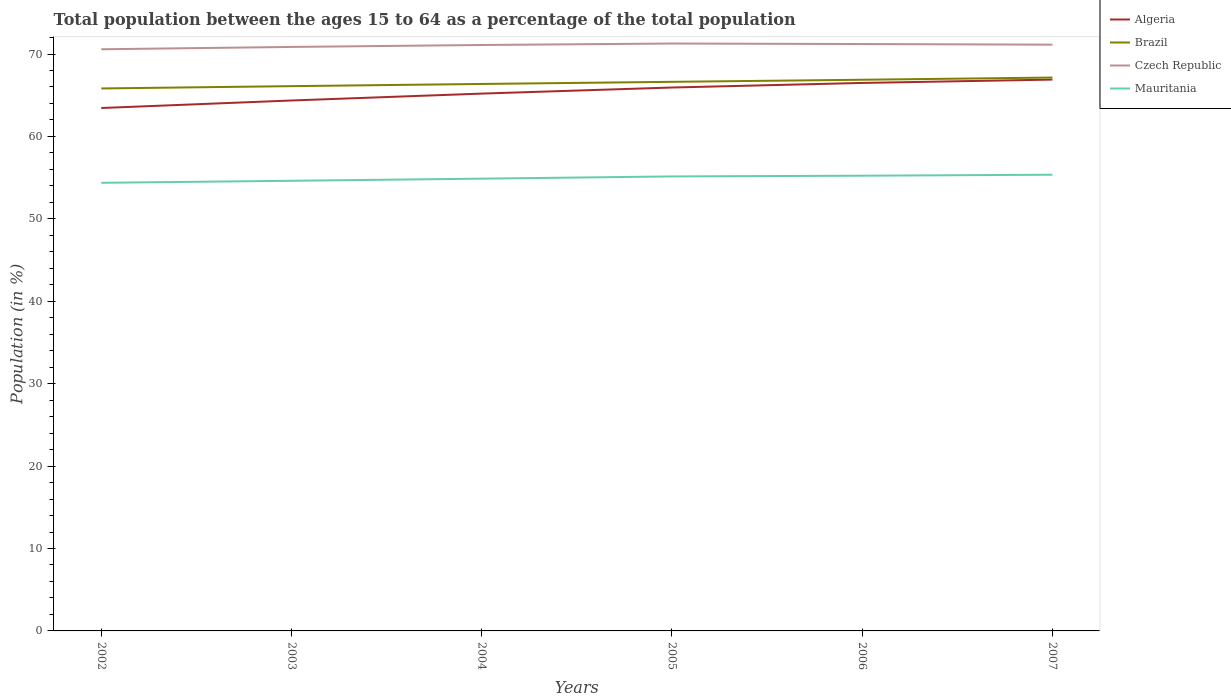How many different coloured lines are there?
Give a very brief answer. 4. Across all years, what is the maximum percentage of the population ages 15 to 64 in Algeria?
Provide a succinct answer. 63.45. What is the total percentage of the population ages 15 to 64 in Brazil in the graph?
Keep it short and to the point. -0.27. What is the difference between the highest and the second highest percentage of the population ages 15 to 64 in Algeria?
Give a very brief answer. 3.45. Is the percentage of the population ages 15 to 64 in Mauritania strictly greater than the percentage of the population ages 15 to 64 in Czech Republic over the years?
Your answer should be compact. Yes. How many lines are there?
Your answer should be very brief. 4. How many years are there in the graph?
Provide a short and direct response. 6. What is the difference between two consecutive major ticks on the Y-axis?
Your answer should be very brief. 10. Are the values on the major ticks of Y-axis written in scientific E-notation?
Provide a succinct answer. No. Does the graph contain any zero values?
Provide a short and direct response. No. Where does the legend appear in the graph?
Provide a succinct answer. Top right. How many legend labels are there?
Make the answer very short. 4. What is the title of the graph?
Keep it short and to the point. Total population between the ages 15 to 64 as a percentage of the total population. What is the label or title of the Y-axis?
Give a very brief answer. Population (in %). What is the Population (in %) of Algeria in 2002?
Your answer should be compact. 63.45. What is the Population (in %) of Brazil in 2002?
Make the answer very short. 65.82. What is the Population (in %) in Czech Republic in 2002?
Your answer should be very brief. 70.57. What is the Population (in %) in Mauritania in 2002?
Keep it short and to the point. 54.37. What is the Population (in %) of Algeria in 2003?
Your answer should be very brief. 64.36. What is the Population (in %) in Brazil in 2003?
Your answer should be compact. 66.1. What is the Population (in %) of Czech Republic in 2003?
Provide a short and direct response. 70.86. What is the Population (in %) of Mauritania in 2003?
Offer a very short reply. 54.62. What is the Population (in %) of Algeria in 2004?
Give a very brief answer. 65.2. What is the Population (in %) of Brazil in 2004?
Your response must be concise. 66.37. What is the Population (in %) in Czech Republic in 2004?
Make the answer very short. 71.09. What is the Population (in %) of Mauritania in 2004?
Keep it short and to the point. 54.88. What is the Population (in %) in Algeria in 2005?
Your response must be concise. 65.93. What is the Population (in %) in Brazil in 2005?
Your response must be concise. 66.62. What is the Population (in %) in Czech Republic in 2005?
Ensure brevity in your answer.  71.27. What is the Population (in %) in Mauritania in 2005?
Keep it short and to the point. 55.15. What is the Population (in %) of Algeria in 2006?
Give a very brief answer. 66.49. What is the Population (in %) in Brazil in 2006?
Your answer should be compact. 66.88. What is the Population (in %) of Czech Republic in 2006?
Your response must be concise. 71.21. What is the Population (in %) of Mauritania in 2006?
Ensure brevity in your answer.  55.23. What is the Population (in %) in Algeria in 2007?
Offer a very short reply. 66.9. What is the Population (in %) in Brazil in 2007?
Your answer should be very brief. 67.14. What is the Population (in %) in Czech Republic in 2007?
Offer a very short reply. 71.13. What is the Population (in %) in Mauritania in 2007?
Your answer should be very brief. 55.35. Across all years, what is the maximum Population (in %) in Algeria?
Offer a terse response. 66.9. Across all years, what is the maximum Population (in %) of Brazil?
Make the answer very short. 67.14. Across all years, what is the maximum Population (in %) in Czech Republic?
Offer a very short reply. 71.27. Across all years, what is the maximum Population (in %) in Mauritania?
Make the answer very short. 55.35. Across all years, what is the minimum Population (in %) in Algeria?
Make the answer very short. 63.45. Across all years, what is the minimum Population (in %) of Brazil?
Give a very brief answer. 65.82. Across all years, what is the minimum Population (in %) of Czech Republic?
Your answer should be compact. 70.57. Across all years, what is the minimum Population (in %) of Mauritania?
Ensure brevity in your answer.  54.37. What is the total Population (in %) of Algeria in the graph?
Provide a short and direct response. 392.32. What is the total Population (in %) of Brazil in the graph?
Your answer should be very brief. 398.93. What is the total Population (in %) in Czech Republic in the graph?
Ensure brevity in your answer.  426.14. What is the total Population (in %) in Mauritania in the graph?
Provide a succinct answer. 329.6. What is the difference between the Population (in %) of Algeria in 2002 and that in 2003?
Your answer should be very brief. -0.91. What is the difference between the Population (in %) in Brazil in 2002 and that in 2003?
Offer a terse response. -0.28. What is the difference between the Population (in %) in Czech Republic in 2002 and that in 2003?
Ensure brevity in your answer.  -0.28. What is the difference between the Population (in %) of Mauritania in 2002 and that in 2003?
Give a very brief answer. -0.24. What is the difference between the Population (in %) of Algeria in 2002 and that in 2004?
Your answer should be compact. -1.75. What is the difference between the Population (in %) of Brazil in 2002 and that in 2004?
Give a very brief answer. -0.55. What is the difference between the Population (in %) in Czech Republic in 2002 and that in 2004?
Offer a terse response. -0.52. What is the difference between the Population (in %) of Mauritania in 2002 and that in 2004?
Keep it short and to the point. -0.5. What is the difference between the Population (in %) of Algeria in 2002 and that in 2005?
Your answer should be compact. -2.49. What is the difference between the Population (in %) in Brazil in 2002 and that in 2005?
Give a very brief answer. -0.8. What is the difference between the Population (in %) in Czech Republic in 2002 and that in 2005?
Ensure brevity in your answer.  -0.7. What is the difference between the Population (in %) in Mauritania in 2002 and that in 2005?
Your response must be concise. -0.77. What is the difference between the Population (in %) of Algeria in 2002 and that in 2006?
Keep it short and to the point. -3.04. What is the difference between the Population (in %) in Brazil in 2002 and that in 2006?
Your response must be concise. -1.05. What is the difference between the Population (in %) of Czech Republic in 2002 and that in 2006?
Offer a terse response. -0.64. What is the difference between the Population (in %) of Mauritania in 2002 and that in 2006?
Your response must be concise. -0.86. What is the difference between the Population (in %) of Algeria in 2002 and that in 2007?
Offer a very short reply. -3.45. What is the difference between the Population (in %) of Brazil in 2002 and that in 2007?
Offer a terse response. -1.32. What is the difference between the Population (in %) in Czech Republic in 2002 and that in 2007?
Your answer should be compact. -0.56. What is the difference between the Population (in %) of Mauritania in 2002 and that in 2007?
Provide a short and direct response. -0.98. What is the difference between the Population (in %) of Algeria in 2003 and that in 2004?
Keep it short and to the point. -0.84. What is the difference between the Population (in %) of Brazil in 2003 and that in 2004?
Provide a succinct answer. -0.27. What is the difference between the Population (in %) in Czech Republic in 2003 and that in 2004?
Provide a short and direct response. -0.24. What is the difference between the Population (in %) in Mauritania in 2003 and that in 2004?
Your answer should be compact. -0.26. What is the difference between the Population (in %) of Algeria in 2003 and that in 2005?
Make the answer very short. -1.57. What is the difference between the Population (in %) of Brazil in 2003 and that in 2005?
Your answer should be very brief. -0.52. What is the difference between the Population (in %) of Czech Republic in 2003 and that in 2005?
Ensure brevity in your answer.  -0.41. What is the difference between the Population (in %) in Mauritania in 2003 and that in 2005?
Give a very brief answer. -0.53. What is the difference between the Population (in %) of Algeria in 2003 and that in 2006?
Ensure brevity in your answer.  -2.13. What is the difference between the Population (in %) in Brazil in 2003 and that in 2006?
Your response must be concise. -0.78. What is the difference between the Population (in %) in Czech Republic in 2003 and that in 2006?
Offer a terse response. -0.35. What is the difference between the Population (in %) of Mauritania in 2003 and that in 2006?
Offer a terse response. -0.62. What is the difference between the Population (in %) of Algeria in 2003 and that in 2007?
Ensure brevity in your answer.  -2.54. What is the difference between the Population (in %) in Brazil in 2003 and that in 2007?
Offer a very short reply. -1.04. What is the difference between the Population (in %) in Czech Republic in 2003 and that in 2007?
Offer a very short reply. -0.28. What is the difference between the Population (in %) in Mauritania in 2003 and that in 2007?
Your answer should be very brief. -0.74. What is the difference between the Population (in %) in Algeria in 2004 and that in 2005?
Your response must be concise. -0.74. What is the difference between the Population (in %) in Brazil in 2004 and that in 2005?
Make the answer very short. -0.26. What is the difference between the Population (in %) in Czech Republic in 2004 and that in 2005?
Make the answer very short. -0.18. What is the difference between the Population (in %) in Mauritania in 2004 and that in 2005?
Offer a very short reply. -0.27. What is the difference between the Population (in %) in Algeria in 2004 and that in 2006?
Your answer should be compact. -1.29. What is the difference between the Population (in %) in Brazil in 2004 and that in 2006?
Provide a short and direct response. -0.51. What is the difference between the Population (in %) in Czech Republic in 2004 and that in 2006?
Ensure brevity in your answer.  -0.12. What is the difference between the Population (in %) of Mauritania in 2004 and that in 2006?
Keep it short and to the point. -0.36. What is the difference between the Population (in %) in Algeria in 2004 and that in 2007?
Your answer should be compact. -1.7. What is the difference between the Population (in %) in Brazil in 2004 and that in 2007?
Offer a terse response. -0.78. What is the difference between the Population (in %) of Czech Republic in 2004 and that in 2007?
Offer a very short reply. -0.04. What is the difference between the Population (in %) of Mauritania in 2004 and that in 2007?
Your answer should be very brief. -0.48. What is the difference between the Population (in %) of Algeria in 2005 and that in 2006?
Your answer should be very brief. -0.55. What is the difference between the Population (in %) of Brazil in 2005 and that in 2006?
Make the answer very short. -0.25. What is the difference between the Population (in %) of Czech Republic in 2005 and that in 2006?
Give a very brief answer. 0.06. What is the difference between the Population (in %) of Mauritania in 2005 and that in 2006?
Provide a short and direct response. -0.09. What is the difference between the Population (in %) of Algeria in 2005 and that in 2007?
Provide a succinct answer. -0.96. What is the difference between the Population (in %) in Brazil in 2005 and that in 2007?
Keep it short and to the point. -0.52. What is the difference between the Population (in %) in Czech Republic in 2005 and that in 2007?
Make the answer very short. 0.14. What is the difference between the Population (in %) of Mauritania in 2005 and that in 2007?
Keep it short and to the point. -0.21. What is the difference between the Population (in %) in Algeria in 2006 and that in 2007?
Your response must be concise. -0.41. What is the difference between the Population (in %) of Brazil in 2006 and that in 2007?
Your answer should be very brief. -0.27. What is the difference between the Population (in %) in Czech Republic in 2006 and that in 2007?
Give a very brief answer. 0.08. What is the difference between the Population (in %) of Mauritania in 2006 and that in 2007?
Give a very brief answer. -0.12. What is the difference between the Population (in %) in Algeria in 2002 and the Population (in %) in Brazil in 2003?
Offer a terse response. -2.65. What is the difference between the Population (in %) of Algeria in 2002 and the Population (in %) of Czech Republic in 2003?
Provide a succinct answer. -7.41. What is the difference between the Population (in %) in Algeria in 2002 and the Population (in %) in Mauritania in 2003?
Offer a terse response. 8.83. What is the difference between the Population (in %) of Brazil in 2002 and the Population (in %) of Czech Republic in 2003?
Make the answer very short. -5.04. What is the difference between the Population (in %) of Brazil in 2002 and the Population (in %) of Mauritania in 2003?
Make the answer very short. 11.2. What is the difference between the Population (in %) in Czech Republic in 2002 and the Population (in %) in Mauritania in 2003?
Your response must be concise. 15.96. What is the difference between the Population (in %) of Algeria in 2002 and the Population (in %) of Brazil in 2004?
Ensure brevity in your answer.  -2.92. What is the difference between the Population (in %) of Algeria in 2002 and the Population (in %) of Czech Republic in 2004?
Offer a very short reply. -7.65. What is the difference between the Population (in %) of Algeria in 2002 and the Population (in %) of Mauritania in 2004?
Ensure brevity in your answer.  8.57. What is the difference between the Population (in %) of Brazil in 2002 and the Population (in %) of Czech Republic in 2004?
Make the answer very short. -5.27. What is the difference between the Population (in %) of Brazil in 2002 and the Population (in %) of Mauritania in 2004?
Offer a terse response. 10.95. What is the difference between the Population (in %) in Czech Republic in 2002 and the Population (in %) in Mauritania in 2004?
Your response must be concise. 15.7. What is the difference between the Population (in %) in Algeria in 2002 and the Population (in %) in Brazil in 2005?
Offer a very short reply. -3.18. What is the difference between the Population (in %) of Algeria in 2002 and the Population (in %) of Czech Republic in 2005?
Provide a short and direct response. -7.82. What is the difference between the Population (in %) of Algeria in 2002 and the Population (in %) of Mauritania in 2005?
Your answer should be compact. 8.3. What is the difference between the Population (in %) of Brazil in 2002 and the Population (in %) of Czech Republic in 2005?
Provide a short and direct response. -5.45. What is the difference between the Population (in %) in Brazil in 2002 and the Population (in %) in Mauritania in 2005?
Provide a short and direct response. 10.67. What is the difference between the Population (in %) of Czech Republic in 2002 and the Population (in %) of Mauritania in 2005?
Your answer should be very brief. 15.43. What is the difference between the Population (in %) of Algeria in 2002 and the Population (in %) of Brazil in 2006?
Ensure brevity in your answer.  -3.43. What is the difference between the Population (in %) in Algeria in 2002 and the Population (in %) in Czech Republic in 2006?
Provide a short and direct response. -7.76. What is the difference between the Population (in %) of Algeria in 2002 and the Population (in %) of Mauritania in 2006?
Ensure brevity in your answer.  8.21. What is the difference between the Population (in %) in Brazil in 2002 and the Population (in %) in Czech Republic in 2006?
Give a very brief answer. -5.39. What is the difference between the Population (in %) in Brazil in 2002 and the Population (in %) in Mauritania in 2006?
Your response must be concise. 10.59. What is the difference between the Population (in %) of Czech Republic in 2002 and the Population (in %) of Mauritania in 2006?
Give a very brief answer. 15.34. What is the difference between the Population (in %) in Algeria in 2002 and the Population (in %) in Brazil in 2007?
Ensure brevity in your answer.  -3.7. What is the difference between the Population (in %) of Algeria in 2002 and the Population (in %) of Czech Republic in 2007?
Provide a succinct answer. -7.69. What is the difference between the Population (in %) of Algeria in 2002 and the Population (in %) of Mauritania in 2007?
Offer a very short reply. 8.09. What is the difference between the Population (in %) of Brazil in 2002 and the Population (in %) of Czech Republic in 2007?
Your answer should be compact. -5.31. What is the difference between the Population (in %) in Brazil in 2002 and the Population (in %) in Mauritania in 2007?
Keep it short and to the point. 10.47. What is the difference between the Population (in %) in Czech Republic in 2002 and the Population (in %) in Mauritania in 2007?
Give a very brief answer. 15.22. What is the difference between the Population (in %) of Algeria in 2003 and the Population (in %) of Brazil in 2004?
Keep it short and to the point. -2.01. What is the difference between the Population (in %) in Algeria in 2003 and the Population (in %) in Czech Republic in 2004?
Offer a very short reply. -6.73. What is the difference between the Population (in %) of Algeria in 2003 and the Population (in %) of Mauritania in 2004?
Give a very brief answer. 9.48. What is the difference between the Population (in %) of Brazil in 2003 and the Population (in %) of Czech Republic in 2004?
Offer a very short reply. -4.99. What is the difference between the Population (in %) of Brazil in 2003 and the Population (in %) of Mauritania in 2004?
Make the answer very short. 11.23. What is the difference between the Population (in %) in Czech Republic in 2003 and the Population (in %) in Mauritania in 2004?
Offer a very short reply. 15.98. What is the difference between the Population (in %) in Algeria in 2003 and the Population (in %) in Brazil in 2005?
Provide a succinct answer. -2.26. What is the difference between the Population (in %) of Algeria in 2003 and the Population (in %) of Czech Republic in 2005?
Your response must be concise. -6.91. What is the difference between the Population (in %) of Algeria in 2003 and the Population (in %) of Mauritania in 2005?
Provide a succinct answer. 9.21. What is the difference between the Population (in %) of Brazil in 2003 and the Population (in %) of Czech Republic in 2005?
Keep it short and to the point. -5.17. What is the difference between the Population (in %) in Brazil in 2003 and the Population (in %) in Mauritania in 2005?
Your answer should be very brief. 10.95. What is the difference between the Population (in %) of Czech Republic in 2003 and the Population (in %) of Mauritania in 2005?
Your answer should be compact. 15.71. What is the difference between the Population (in %) in Algeria in 2003 and the Population (in %) in Brazil in 2006?
Ensure brevity in your answer.  -2.52. What is the difference between the Population (in %) in Algeria in 2003 and the Population (in %) in Czech Republic in 2006?
Keep it short and to the point. -6.85. What is the difference between the Population (in %) in Algeria in 2003 and the Population (in %) in Mauritania in 2006?
Provide a short and direct response. 9.13. What is the difference between the Population (in %) of Brazil in 2003 and the Population (in %) of Czech Republic in 2006?
Offer a terse response. -5.11. What is the difference between the Population (in %) of Brazil in 2003 and the Population (in %) of Mauritania in 2006?
Offer a terse response. 10.87. What is the difference between the Population (in %) in Czech Republic in 2003 and the Population (in %) in Mauritania in 2006?
Give a very brief answer. 15.62. What is the difference between the Population (in %) of Algeria in 2003 and the Population (in %) of Brazil in 2007?
Provide a succinct answer. -2.78. What is the difference between the Population (in %) in Algeria in 2003 and the Population (in %) in Czech Republic in 2007?
Give a very brief answer. -6.77. What is the difference between the Population (in %) in Algeria in 2003 and the Population (in %) in Mauritania in 2007?
Provide a short and direct response. 9.01. What is the difference between the Population (in %) of Brazil in 2003 and the Population (in %) of Czech Republic in 2007?
Give a very brief answer. -5.03. What is the difference between the Population (in %) in Brazil in 2003 and the Population (in %) in Mauritania in 2007?
Ensure brevity in your answer.  10.75. What is the difference between the Population (in %) of Czech Republic in 2003 and the Population (in %) of Mauritania in 2007?
Provide a succinct answer. 15.5. What is the difference between the Population (in %) in Algeria in 2004 and the Population (in %) in Brazil in 2005?
Give a very brief answer. -1.43. What is the difference between the Population (in %) in Algeria in 2004 and the Population (in %) in Czech Republic in 2005?
Offer a very short reply. -6.07. What is the difference between the Population (in %) in Algeria in 2004 and the Population (in %) in Mauritania in 2005?
Give a very brief answer. 10.05. What is the difference between the Population (in %) of Brazil in 2004 and the Population (in %) of Czech Republic in 2005?
Provide a short and direct response. -4.9. What is the difference between the Population (in %) in Brazil in 2004 and the Population (in %) in Mauritania in 2005?
Offer a terse response. 11.22. What is the difference between the Population (in %) of Czech Republic in 2004 and the Population (in %) of Mauritania in 2005?
Give a very brief answer. 15.95. What is the difference between the Population (in %) in Algeria in 2004 and the Population (in %) in Brazil in 2006?
Keep it short and to the point. -1.68. What is the difference between the Population (in %) of Algeria in 2004 and the Population (in %) of Czech Republic in 2006?
Give a very brief answer. -6.01. What is the difference between the Population (in %) of Algeria in 2004 and the Population (in %) of Mauritania in 2006?
Give a very brief answer. 9.96. What is the difference between the Population (in %) in Brazil in 2004 and the Population (in %) in Czech Republic in 2006?
Your answer should be compact. -4.84. What is the difference between the Population (in %) in Brazil in 2004 and the Population (in %) in Mauritania in 2006?
Keep it short and to the point. 11.13. What is the difference between the Population (in %) in Czech Republic in 2004 and the Population (in %) in Mauritania in 2006?
Your answer should be very brief. 15.86. What is the difference between the Population (in %) in Algeria in 2004 and the Population (in %) in Brazil in 2007?
Make the answer very short. -1.95. What is the difference between the Population (in %) in Algeria in 2004 and the Population (in %) in Czech Republic in 2007?
Your answer should be very brief. -5.94. What is the difference between the Population (in %) in Algeria in 2004 and the Population (in %) in Mauritania in 2007?
Offer a terse response. 9.84. What is the difference between the Population (in %) of Brazil in 2004 and the Population (in %) of Czech Republic in 2007?
Make the answer very short. -4.77. What is the difference between the Population (in %) in Brazil in 2004 and the Population (in %) in Mauritania in 2007?
Offer a terse response. 11.01. What is the difference between the Population (in %) in Czech Republic in 2004 and the Population (in %) in Mauritania in 2007?
Offer a terse response. 15.74. What is the difference between the Population (in %) in Algeria in 2005 and the Population (in %) in Brazil in 2006?
Ensure brevity in your answer.  -0.94. What is the difference between the Population (in %) in Algeria in 2005 and the Population (in %) in Czech Republic in 2006?
Keep it short and to the point. -5.28. What is the difference between the Population (in %) of Algeria in 2005 and the Population (in %) of Mauritania in 2006?
Provide a short and direct response. 10.7. What is the difference between the Population (in %) in Brazil in 2005 and the Population (in %) in Czech Republic in 2006?
Ensure brevity in your answer.  -4.59. What is the difference between the Population (in %) of Brazil in 2005 and the Population (in %) of Mauritania in 2006?
Provide a succinct answer. 11.39. What is the difference between the Population (in %) in Czech Republic in 2005 and the Population (in %) in Mauritania in 2006?
Provide a succinct answer. 16.04. What is the difference between the Population (in %) of Algeria in 2005 and the Population (in %) of Brazil in 2007?
Ensure brevity in your answer.  -1.21. What is the difference between the Population (in %) of Algeria in 2005 and the Population (in %) of Czech Republic in 2007?
Your response must be concise. -5.2. What is the difference between the Population (in %) in Algeria in 2005 and the Population (in %) in Mauritania in 2007?
Offer a terse response. 10.58. What is the difference between the Population (in %) of Brazil in 2005 and the Population (in %) of Czech Republic in 2007?
Provide a succinct answer. -4.51. What is the difference between the Population (in %) in Brazil in 2005 and the Population (in %) in Mauritania in 2007?
Provide a succinct answer. 11.27. What is the difference between the Population (in %) of Czech Republic in 2005 and the Population (in %) of Mauritania in 2007?
Your answer should be compact. 15.92. What is the difference between the Population (in %) of Algeria in 2006 and the Population (in %) of Brazil in 2007?
Offer a very short reply. -0.66. What is the difference between the Population (in %) of Algeria in 2006 and the Population (in %) of Czech Republic in 2007?
Your response must be concise. -4.64. What is the difference between the Population (in %) in Algeria in 2006 and the Population (in %) in Mauritania in 2007?
Make the answer very short. 11.14. What is the difference between the Population (in %) of Brazil in 2006 and the Population (in %) of Czech Republic in 2007?
Make the answer very short. -4.26. What is the difference between the Population (in %) in Brazil in 2006 and the Population (in %) in Mauritania in 2007?
Your response must be concise. 11.52. What is the difference between the Population (in %) of Czech Republic in 2006 and the Population (in %) of Mauritania in 2007?
Your answer should be very brief. 15.86. What is the average Population (in %) of Algeria per year?
Make the answer very short. 65.39. What is the average Population (in %) of Brazil per year?
Provide a short and direct response. 66.49. What is the average Population (in %) of Czech Republic per year?
Keep it short and to the point. 71.02. What is the average Population (in %) of Mauritania per year?
Keep it short and to the point. 54.93. In the year 2002, what is the difference between the Population (in %) of Algeria and Population (in %) of Brazil?
Ensure brevity in your answer.  -2.37. In the year 2002, what is the difference between the Population (in %) in Algeria and Population (in %) in Czech Republic?
Offer a terse response. -7.13. In the year 2002, what is the difference between the Population (in %) of Algeria and Population (in %) of Mauritania?
Your response must be concise. 9.07. In the year 2002, what is the difference between the Population (in %) in Brazil and Population (in %) in Czech Republic?
Provide a succinct answer. -4.75. In the year 2002, what is the difference between the Population (in %) of Brazil and Population (in %) of Mauritania?
Keep it short and to the point. 11.45. In the year 2002, what is the difference between the Population (in %) of Czech Republic and Population (in %) of Mauritania?
Ensure brevity in your answer.  16.2. In the year 2003, what is the difference between the Population (in %) of Algeria and Population (in %) of Brazil?
Offer a terse response. -1.74. In the year 2003, what is the difference between the Population (in %) in Algeria and Population (in %) in Czech Republic?
Your answer should be compact. -6.5. In the year 2003, what is the difference between the Population (in %) in Algeria and Population (in %) in Mauritania?
Your response must be concise. 9.74. In the year 2003, what is the difference between the Population (in %) in Brazil and Population (in %) in Czech Republic?
Your answer should be compact. -4.76. In the year 2003, what is the difference between the Population (in %) of Brazil and Population (in %) of Mauritania?
Ensure brevity in your answer.  11.48. In the year 2003, what is the difference between the Population (in %) in Czech Republic and Population (in %) in Mauritania?
Provide a succinct answer. 16.24. In the year 2004, what is the difference between the Population (in %) in Algeria and Population (in %) in Brazil?
Your response must be concise. -1.17. In the year 2004, what is the difference between the Population (in %) in Algeria and Population (in %) in Czech Republic?
Offer a terse response. -5.9. In the year 2004, what is the difference between the Population (in %) of Algeria and Population (in %) of Mauritania?
Offer a terse response. 10.32. In the year 2004, what is the difference between the Population (in %) of Brazil and Population (in %) of Czech Republic?
Give a very brief answer. -4.73. In the year 2004, what is the difference between the Population (in %) in Brazil and Population (in %) in Mauritania?
Offer a terse response. 11.49. In the year 2004, what is the difference between the Population (in %) of Czech Republic and Population (in %) of Mauritania?
Offer a very short reply. 16.22. In the year 2005, what is the difference between the Population (in %) in Algeria and Population (in %) in Brazil?
Ensure brevity in your answer.  -0.69. In the year 2005, what is the difference between the Population (in %) in Algeria and Population (in %) in Czech Republic?
Offer a very short reply. -5.34. In the year 2005, what is the difference between the Population (in %) of Algeria and Population (in %) of Mauritania?
Your response must be concise. 10.79. In the year 2005, what is the difference between the Population (in %) of Brazil and Population (in %) of Czech Republic?
Keep it short and to the point. -4.65. In the year 2005, what is the difference between the Population (in %) of Brazil and Population (in %) of Mauritania?
Give a very brief answer. 11.48. In the year 2005, what is the difference between the Population (in %) of Czech Republic and Population (in %) of Mauritania?
Your response must be concise. 16.12. In the year 2006, what is the difference between the Population (in %) of Algeria and Population (in %) of Brazil?
Your answer should be very brief. -0.39. In the year 2006, what is the difference between the Population (in %) of Algeria and Population (in %) of Czech Republic?
Offer a terse response. -4.72. In the year 2006, what is the difference between the Population (in %) of Algeria and Population (in %) of Mauritania?
Make the answer very short. 11.25. In the year 2006, what is the difference between the Population (in %) in Brazil and Population (in %) in Czech Republic?
Offer a terse response. -4.34. In the year 2006, what is the difference between the Population (in %) in Brazil and Population (in %) in Mauritania?
Ensure brevity in your answer.  11.64. In the year 2006, what is the difference between the Population (in %) in Czech Republic and Population (in %) in Mauritania?
Keep it short and to the point. 15.98. In the year 2007, what is the difference between the Population (in %) of Algeria and Population (in %) of Brazil?
Offer a terse response. -0.25. In the year 2007, what is the difference between the Population (in %) of Algeria and Population (in %) of Czech Republic?
Keep it short and to the point. -4.24. In the year 2007, what is the difference between the Population (in %) in Algeria and Population (in %) in Mauritania?
Your answer should be compact. 11.54. In the year 2007, what is the difference between the Population (in %) in Brazil and Population (in %) in Czech Republic?
Offer a very short reply. -3.99. In the year 2007, what is the difference between the Population (in %) in Brazil and Population (in %) in Mauritania?
Your answer should be very brief. 11.79. In the year 2007, what is the difference between the Population (in %) of Czech Republic and Population (in %) of Mauritania?
Ensure brevity in your answer.  15.78. What is the ratio of the Population (in %) of Algeria in 2002 to that in 2003?
Your answer should be compact. 0.99. What is the ratio of the Population (in %) in Brazil in 2002 to that in 2003?
Offer a very short reply. 1. What is the ratio of the Population (in %) in Algeria in 2002 to that in 2004?
Your answer should be compact. 0.97. What is the ratio of the Population (in %) of Czech Republic in 2002 to that in 2004?
Provide a succinct answer. 0.99. What is the ratio of the Population (in %) in Mauritania in 2002 to that in 2004?
Your answer should be compact. 0.99. What is the ratio of the Population (in %) of Algeria in 2002 to that in 2005?
Ensure brevity in your answer.  0.96. What is the ratio of the Population (in %) in Brazil in 2002 to that in 2005?
Make the answer very short. 0.99. What is the ratio of the Population (in %) of Czech Republic in 2002 to that in 2005?
Provide a succinct answer. 0.99. What is the ratio of the Population (in %) in Algeria in 2002 to that in 2006?
Provide a short and direct response. 0.95. What is the ratio of the Population (in %) in Brazil in 2002 to that in 2006?
Provide a short and direct response. 0.98. What is the ratio of the Population (in %) of Czech Republic in 2002 to that in 2006?
Offer a very short reply. 0.99. What is the ratio of the Population (in %) of Mauritania in 2002 to that in 2006?
Offer a terse response. 0.98. What is the ratio of the Population (in %) in Algeria in 2002 to that in 2007?
Your answer should be very brief. 0.95. What is the ratio of the Population (in %) in Brazil in 2002 to that in 2007?
Give a very brief answer. 0.98. What is the ratio of the Population (in %) of Czech Republic in 2002 to that in 2007?
Your answer should be compact. 0.99. What is the ratio of the Population (in %) of Mauritania in 2002 to that in 2007?
Keep it short and to the point. 0.98. What is the ratio of the Population (in %) of Algeria in 2003 to that in 2004?
Ensure brevity in your answer.  0.99. What is the ratio of the Population (in %) in Czech Republic in 2003 to that in 2004?
Give a very brief answer. 1. What is the ratio of the Population (in %) of Mauritania in 2003 to that in 2004?
Offer a terse response. 1. What is the ratio of the Population (in %) in Algeria in 2003 to that in 2005?
Offer a terse response. 0.98. What is the ratio of the Population (in %) in Brazil in 2003 to that in 2005?
Provide a succinct answer. 0.99. What is the ratio of the Population (in %) of Czech Republic in 2003 to that in 2005?
Your answer should be compact. 0.99. What is the ratio of the Population (in %) of Brazil in 2003 to that in 2006?
Your answer should be very brief. 0.99. What is the ratio of the Population (in %) in Algeria in 2003 to that in 2007?
Offer a terse response. 0.96. What is the ratio of the Population (in %) of Brazil in 2003 to that in 2007?
Give a very brief answer. 0.98. What is the ratio of the Population (in %) of Mauritania in 2003 to that in 2007?
Your response must be concise. 0.99. What is the ratio of the Population (in %) in Czech Republic in 2004 to that in 2005?
Offer a terse response. 1. What is the ratio of the Population (in %) of Mauritania in 2004 to that in 2005?
Give a very brief answer. 1. What is the ratio of the Population (in %) in Algeria in 2004 to that in 2006?
Make the answer very short. 0.98. What is the ratio of the Population (in %) in Brazil in 2004 to that in 2006?
Offer a very short reply. 0.99. What is the ratio of the Population (in %) of Czech Republic in 2004 to that in 2006?
Your answer should be compact. 1. What is the ratio of the Population (in %) in Algeria in 2004 to that in 2007?
Ensure brevity in your answer.  0.97. What is the ratio of the Population (in %) of Brazil in 2004 to that in 2007?
Provide a short and direct response. 0.99. What is the ratio of the Population (in %) in Czech Republic in 2004 to that in 2007?
Keep it short and to the point. 1. What is the ratio of the Population (in %) in Algeria in 2005 to that in 2006?
Offer a very short reply. 0.99. What is the ratio of the Population (in %) in Mauritania in 2005 to that in 2006?
Offer a very short reply. 1. What is the ratio of the Population (in %) of Algeria in 2005 to that in 2007?
Make the answer very short. 0.99. What is the ratio of the Population (in %) in Czech Republic in 2005 to that in 2007?
Provide a succinct answer. 1. What is the ratio of the Population (in %) of Mauritania in 2005 to that in 2007?
Your response must be concise. 1. What is the ratio of the Population (in %) of Algeria in 2006 to that in 2007?
Offer a very short reply. 0.99. What is the ratio of the Population (in %) of Brazil in 2006 to that in 2007?
Keep it short and to the point. 1. What is the ratio of the Population (in %) in Mauritania in 2006 to that in 2007?
Offer a very short reply. 1. What is the difference between the highest and the second highest Population (in %) in Algeria?
Offer a terse response. 0.41. What is the difference between the highest and the second highest Population (in %) of Brazil?
Keep it short and to the point. 0.27. What is the difference between the highest and the second highest Population (in %) of Czech Republic?
Your answer should be very brief. 0.06. What is the difference between the highest and the second highest Population (in %) of Mauritania?
Make the answer very short. 0.12. What is the difference between the highest and the lowest Population (in %) in Algeria?
Provide a succinct answer. 3.45. What is the difference between the highest and the lowest Population (in %) in Brazil?
Provide a short and direct response. 1.32. What is the difference between the highest and the lowest Population (in %) of Czech Republic?
Keep it short and to the point. 0.7. What is the difference between the highest and the lowest Population (in %) in Mauritania?
Give a very brief answer. 0.98. 